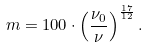<formula> <loc_0><loc_0><loc_500><loc_500>m = 1 0 0 \cdot \left ( \frac { \nu _ { 0 } } { \nu } \right ) ^ { \frac { 1 7 } { 1 2 } } .</formula> 